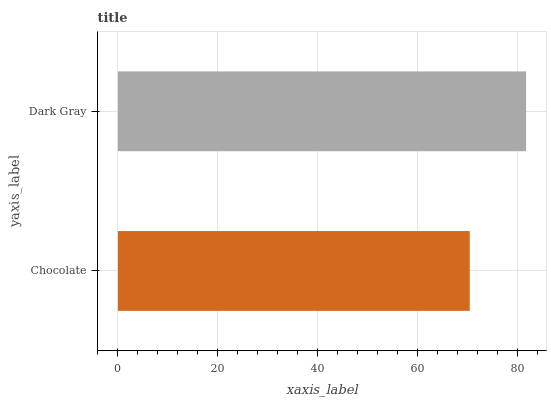Is Chocolate the minimum?
Answer yes or no. Yes. Is Dark Gray the maximum?
Answer yes or no. Yes. Is Dark Gray the minimum?
Answer yes or no. No. Is Dark Gray greater than Chocolate?
Answer yes or no. Yes. Is Chocolate less than Dark Gray?
Answer yes or no. Yes. Is Chocolate greater than Dark Gray?
Answer yes or no. No. Is Dark Gray less than Chocolate?
Answer yes or no. No. Is Dark Gray the high median?
Answer yes or no. Yes. Is Chocolate the low median?
Answer yes or no. Yes. Is Chocolate the high median?
Answer yes or no. No. Is Dark Gray the low median?
Answer yes or no. No. 